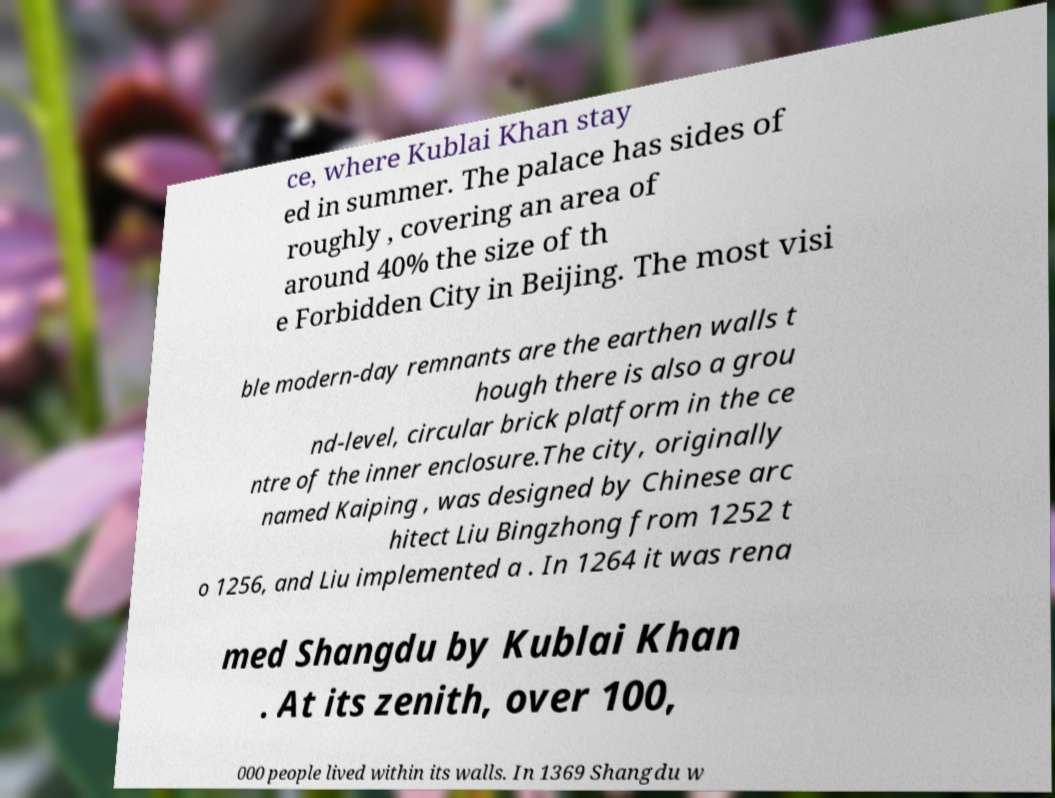There's text embedded in this image that I need extracted. Can you transcribe it verbatim? ce, where Kublai Khan stay ed in summer. The palace has sides of roughly , covering an area of around 40% the size of th e Forbidden City in Beijing. The most visi ble modern-day remnants are the earthen walls t hough there is also a grou nd-level, circular brick platform in the ce ntre of the inner enclosure.The city, originally named Kaiping , was designed by Chinese arc hitect Liu Bingzhong from 1252 t o 1256, and Liu implemented a . In 1264 it was rena med Shangdu by Kublai Khan . At its zenith, over 100, 000 people lived within its walls. In 1369 Shangdu w 